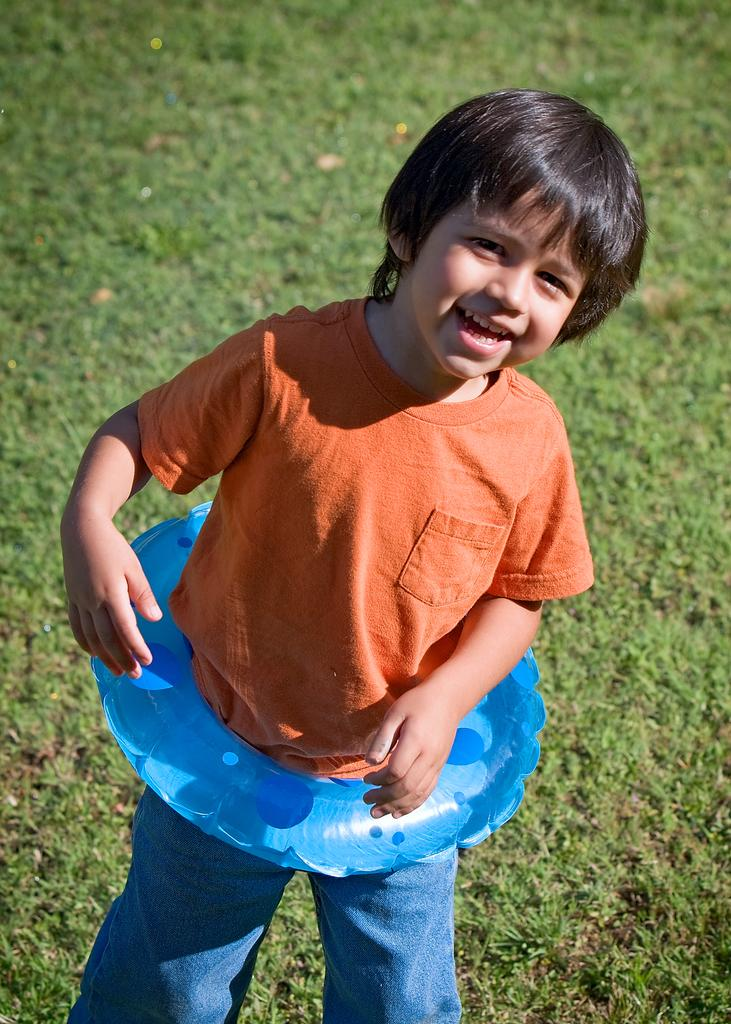What is the main subject of the image? The main subject of the image is a kid. What is the kid wearing in the image? The kid is wearing a tube in the image. What is the kid doing in the image? The kid is standing and posing for a picture in the image. What can be seen in the background of the image? There is grass in the background of the image. What type of pie is the kid holding in the image? There is no pie present in the image; the kid is wearing a tube and posing for a picture. 